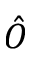<formula> <loc_0><loc_0><loc_500><loc_500>\hat { O }</formula> 